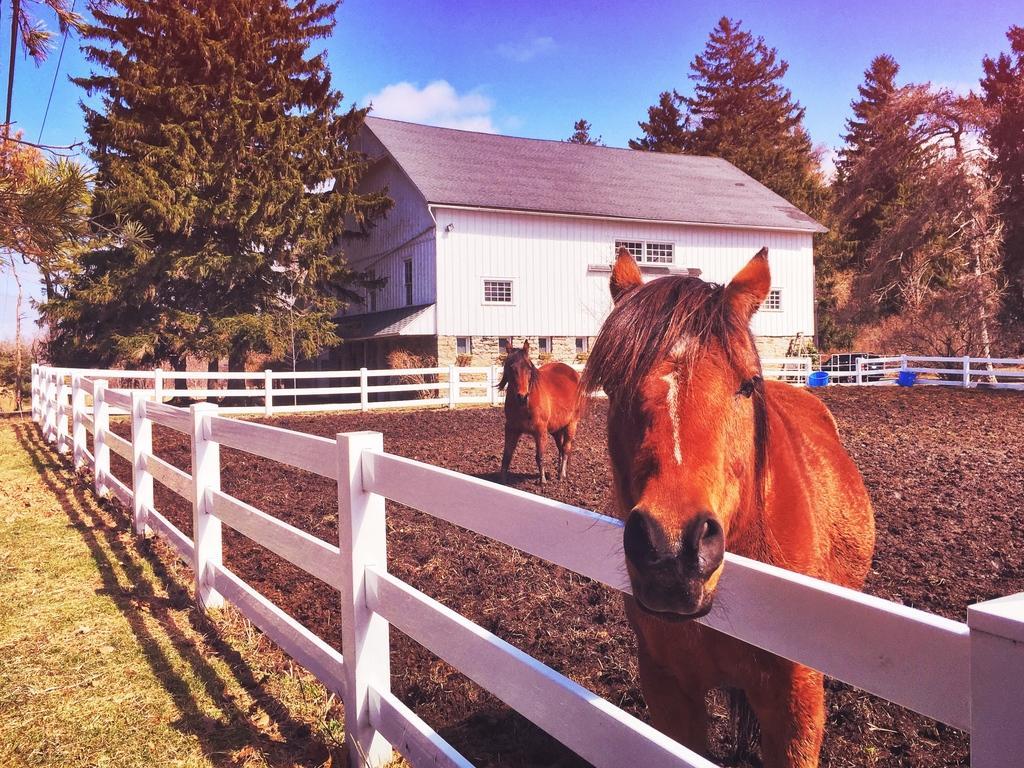How would you summarize this image in a sentence or two? In the picture we can see two horses, around it, we can see the railing and behind it, we can see the house which is white in color and besides it, we can see some trees and a part of the grass surface and in the background we can see the sky with clouds. 